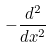Convert formula to latex. <formula><loc_0><loc_0><loc_500><loc_500>- \frac { d ^ { 2 } } { d x ^ { 2 } }</formula> 